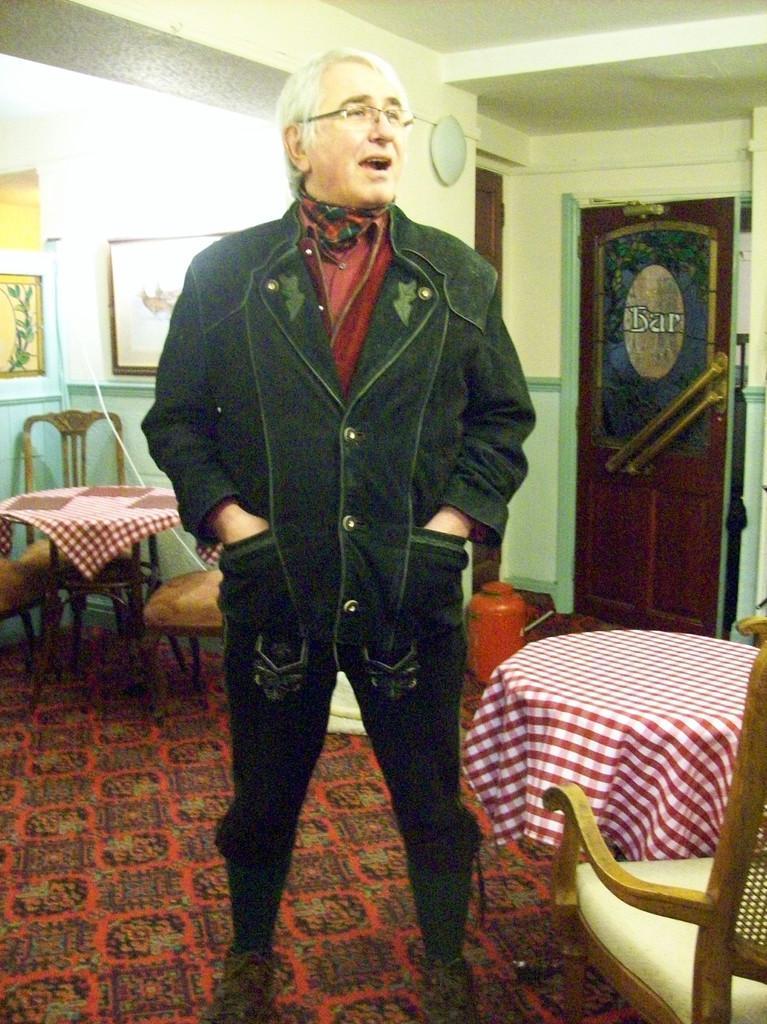Could you give a brief overview of what you see in this image? In the image I can see a person who is wearing the jacket and around there are some tables, chairs and some frames to the wall. 